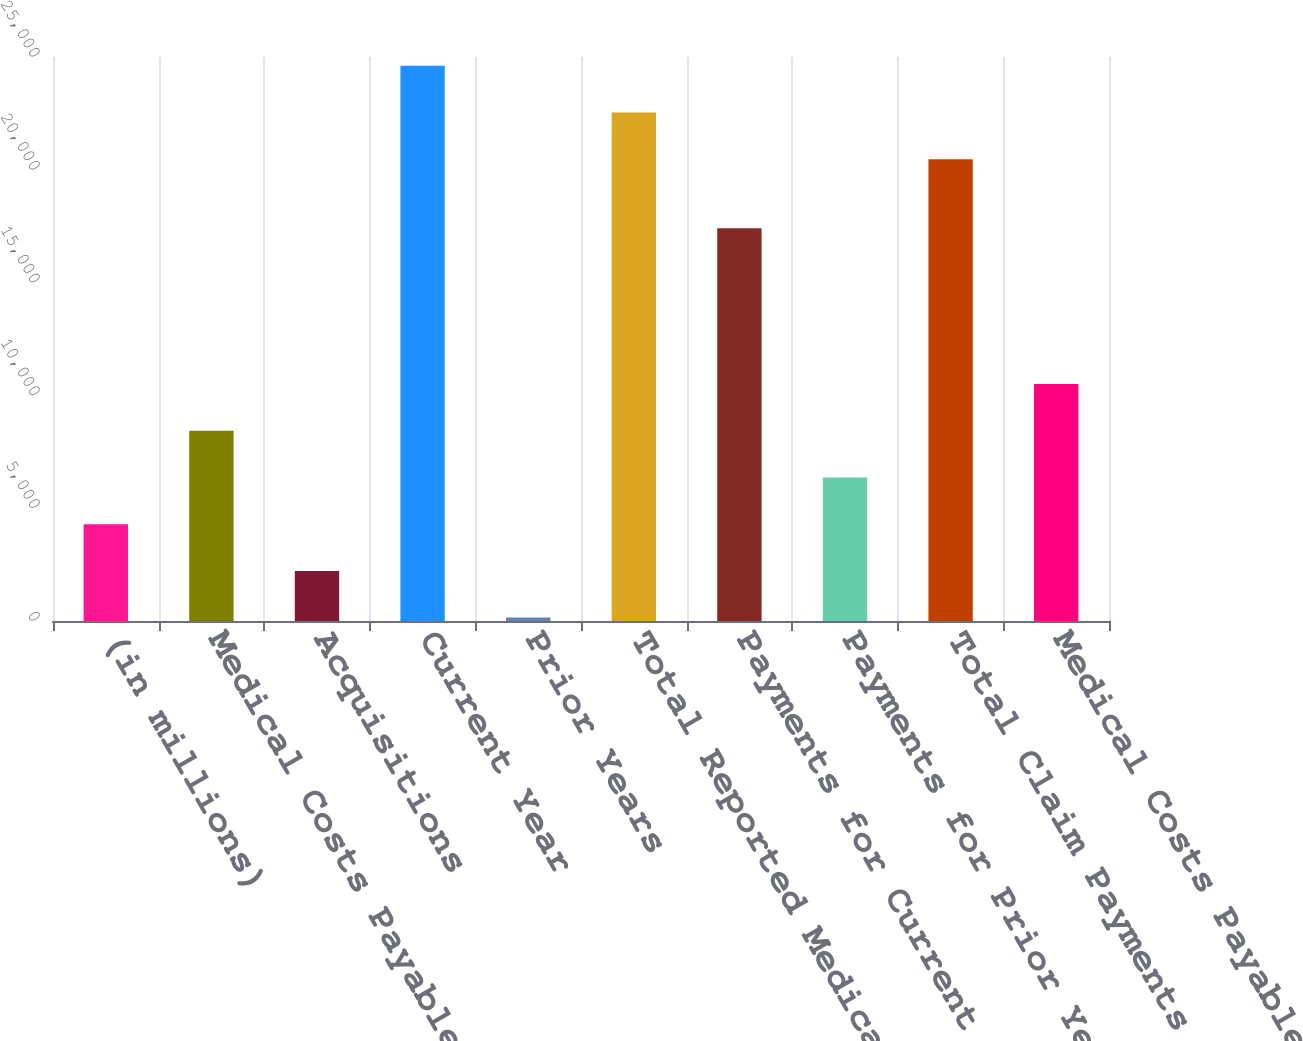<chart> <loc_0><loc_0><loc_500><loc_500><bar_chart><fcel>(in millions)<fcel>Medical Costs Payable<fcel>Acquisitions<fcel>Current Year<fcel>Prior Years<fcel>Total Reported Medical Costs<fcel>Payments for Current Year<fcel>Payments for Prior Years<fcel>Total Claim Payments<fcel>Medical Costs Payable End of<nl><fcel>4292.8<fcel>8435.6<fcel>2221.4<fcel>24610.8<fcel>150<fcel>22539.4<fcel>17411<fcel>6364.2<fcel>20468<fcel>10507<nl></chart> 